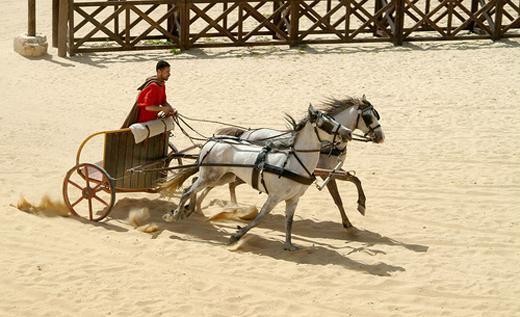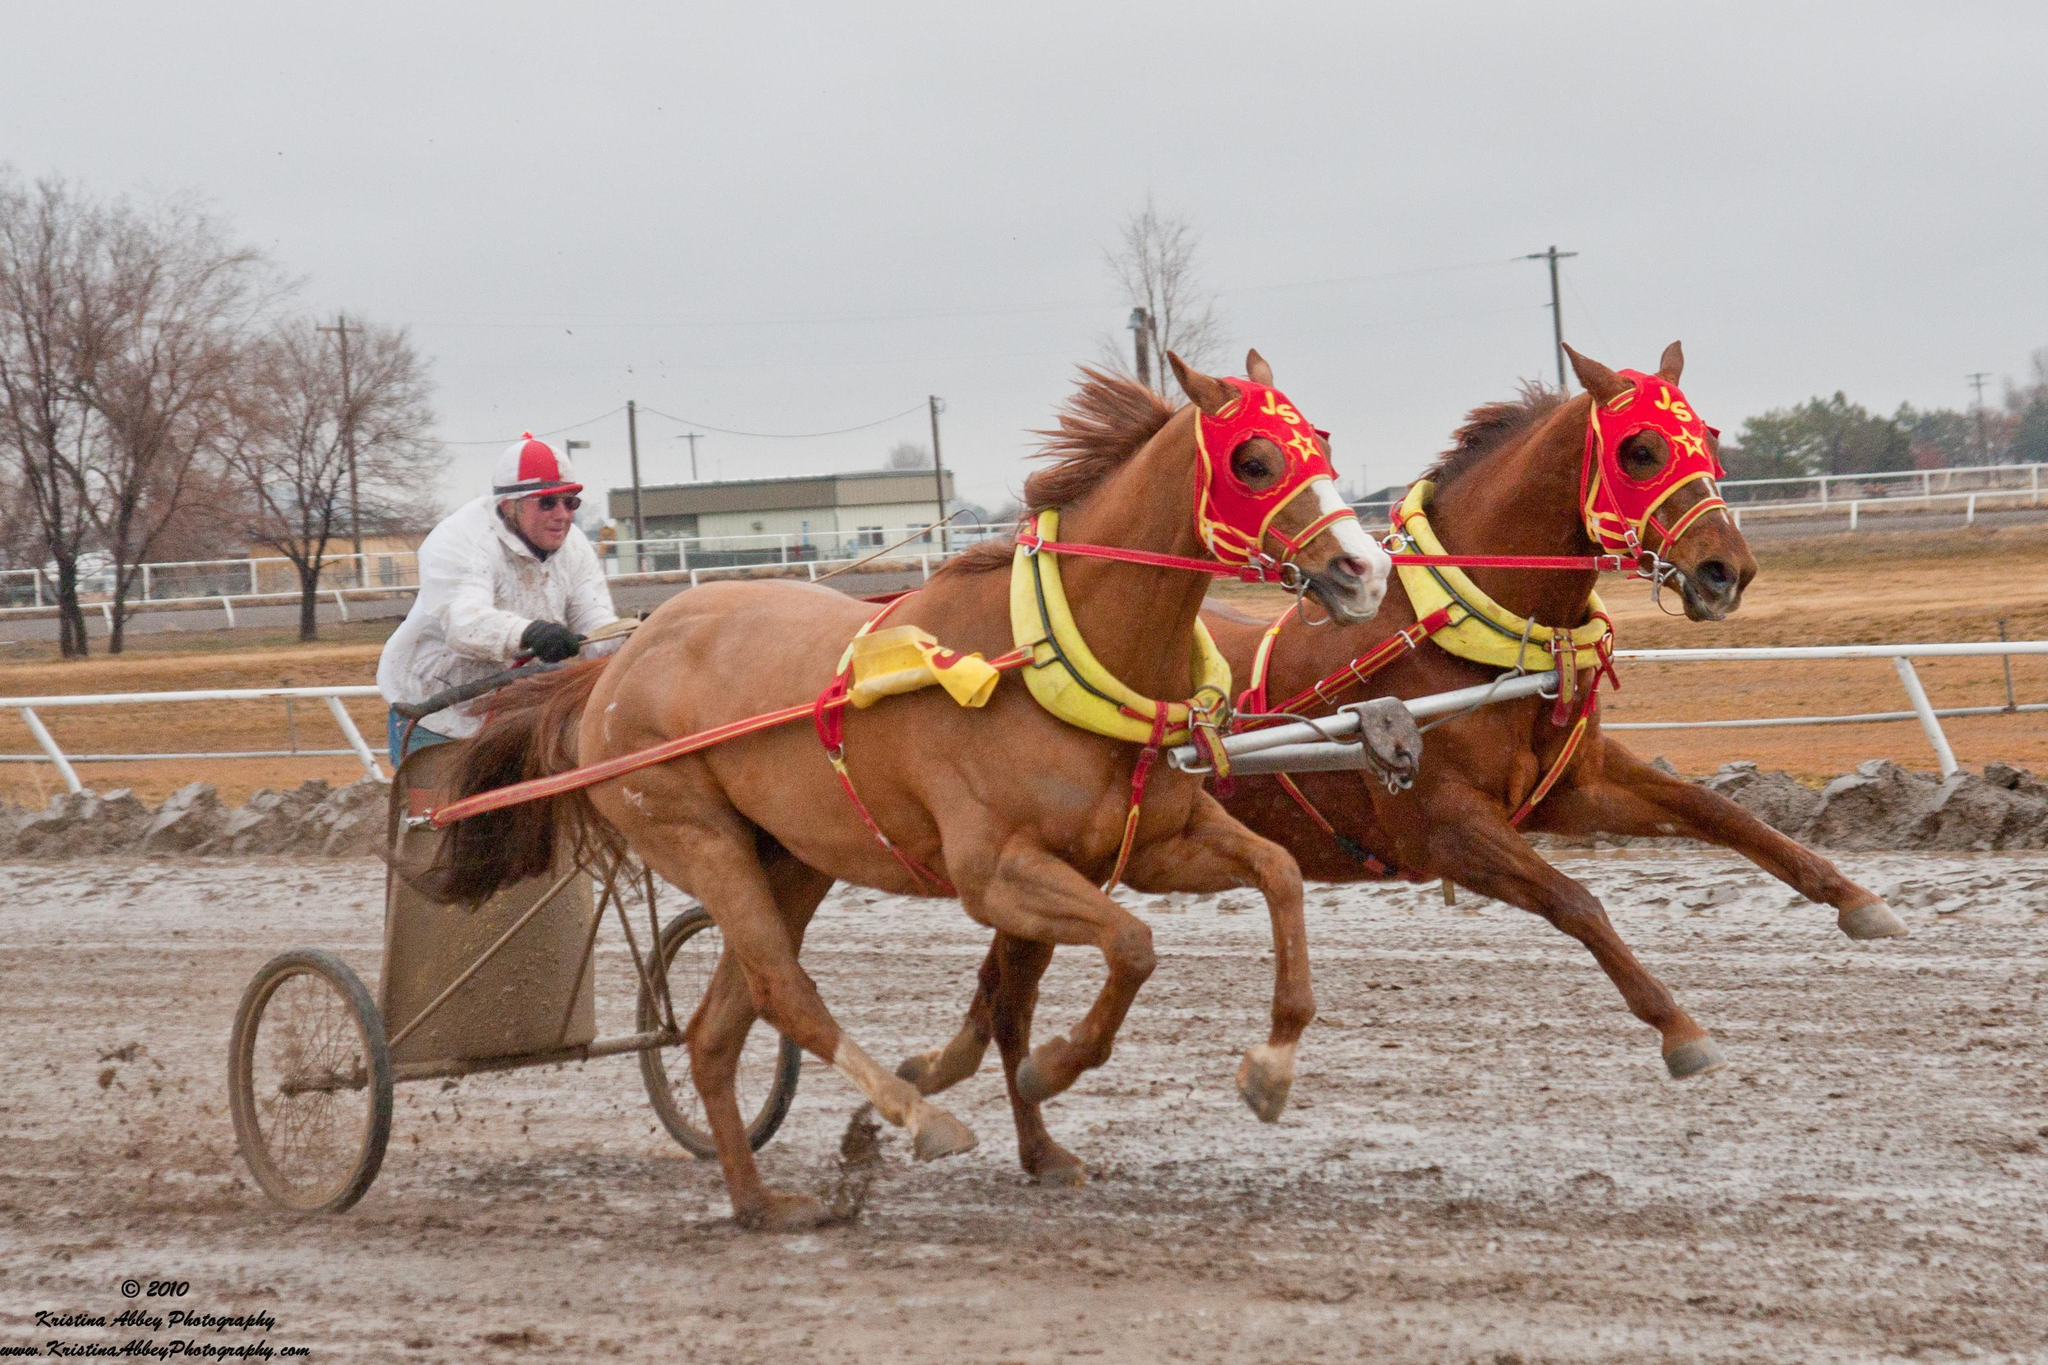The first image is the image on the left, the second image is the image on the right. Considering the images on both sides, is "There are brown horses shown in at least one of the images." valid? Answer yes or no. Yes. The first image is the image on the left, the second image is the image on the right. Given the left and right images, does the statement "At least one image shows a cart pulled by four horses." hold true? Answer yes or no. No. 